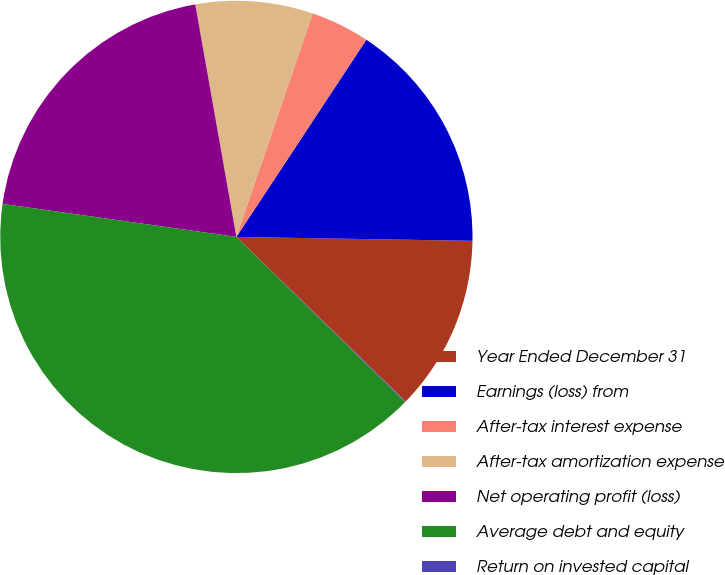Convert chart. <chart><loc_0><loc_0><loc_500><loc_500><pie_chart><fcel>Year Ended December 31<fcel>Earnings (loss) from<fcel>After-tax interest expense<fcel>After-tax amortization expense<fcel>Net operating profit (loss)<fcel>Average debt and equity<fcel>Return on invested capital<nl><fcel>12.01%<fcel>15.99%<fcel>4.04%<fcel>8.02%<fcel>19.98%<fcel>39.91%<fcel>0.05%<nl></chart> 